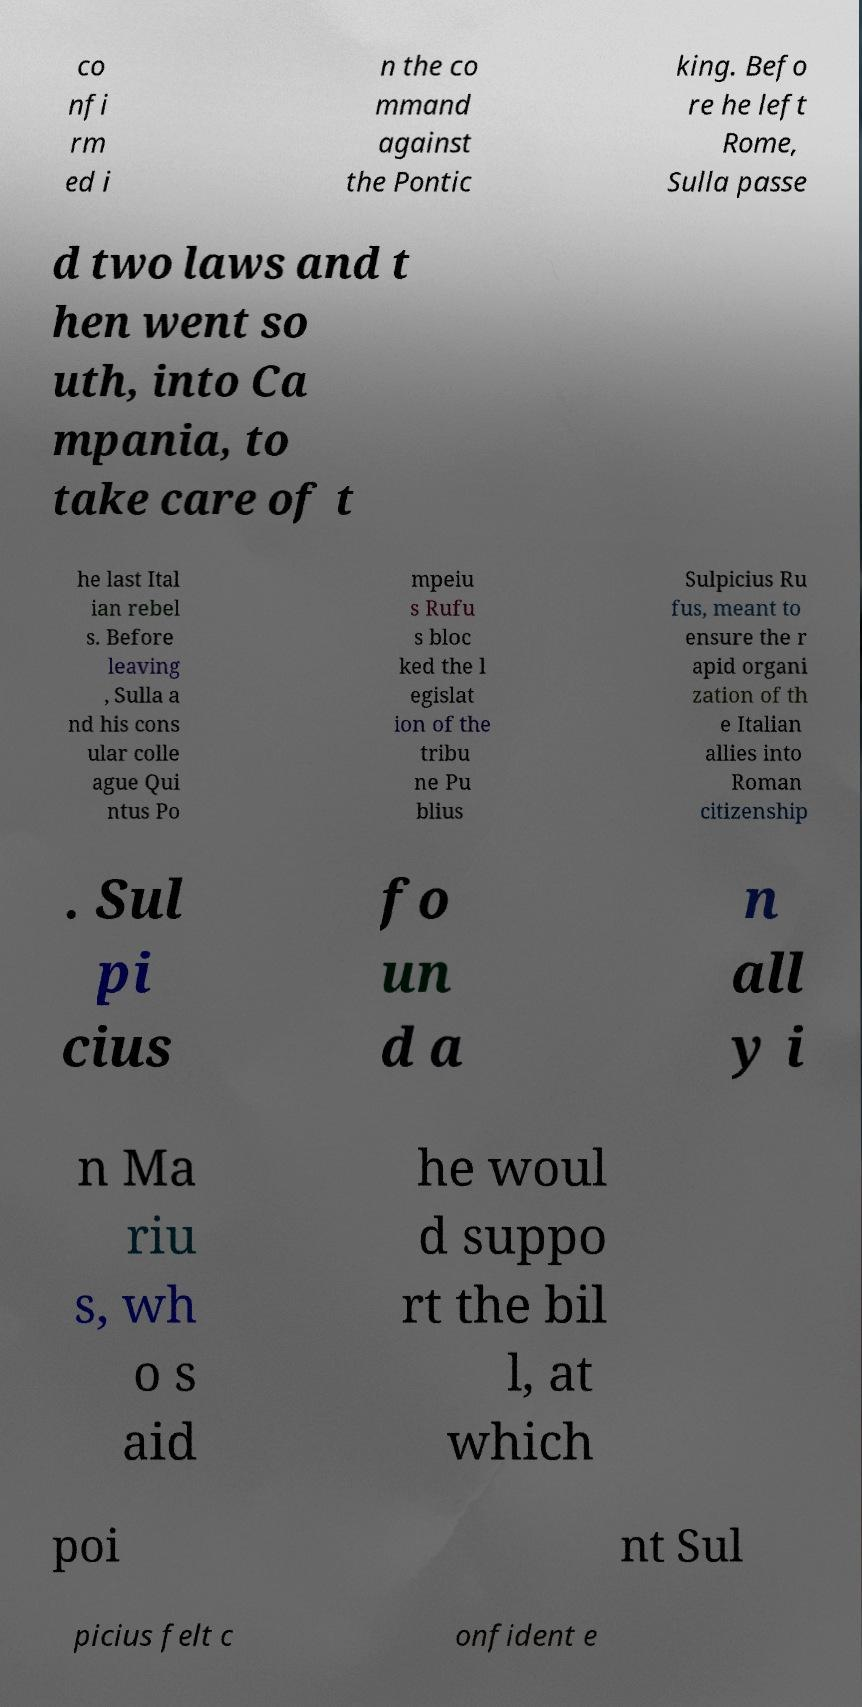For documentation purposes, I need the text within this image transcribed. Could you provide that? co nfi rm ed i n the co mmand against the Pontic king. Befo re he left Rome, Sulla passe d two laws and t hen went so uth, into Ca mpania, to take care of t he last Ital ian rebel s. Before leaving , Sulla a nd his cons ular colle ague Qui ntus Po mpeiu s Rufu s bloc ked the l egislat ion of the tribu ne Pu blius Sulpicius Ru fus, meant to ensure the r apid organi zation of th e Italian allies into Roman citizenship . Sul pi cius fo un d a n all y i n Ma riu s, wh o s aid he woul d suppo rt the bil l, at which poi nt Sul picius felt c onfident e 